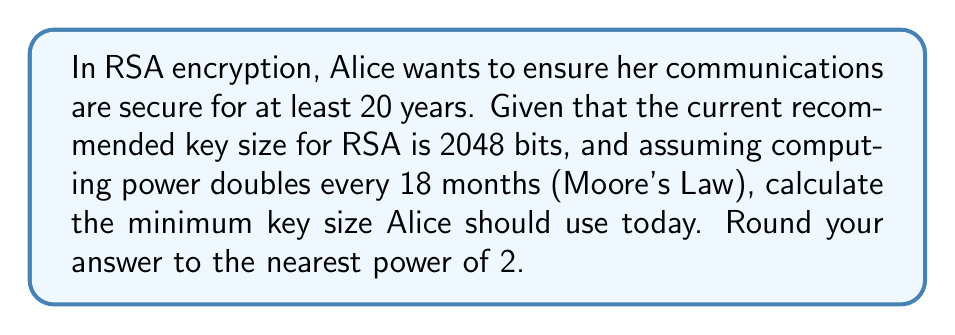Teach me how to tackle this problem. Let's approach this step-by-step:

1) First, we need to calculate how many times computing power will double in 20 years:
   - 20 years = 240 months
   - Number of doublings = 240 / 18 = 13.33

2) Now, we can calculate the factor by which computing power will increase:
   $2^{13.33} \approx 10,321$

3) This means that a 2048-bit key in 20 years will be as secure as a 2048/10,321 ≈ 198-bit key today.

4) To maintain the same level of security, Alice needs to use a key that is 10,321 times larger than 2048 bits:
   $2048 * 10,321 = 21,137,408$ bits

5) Rounding to the nearest power of 2:
   $2^{24} = 16,777,216$ (too small)
   $2^{25} = 33,554,432$ (closest)

Therefore, Alice should use a 33,554,432-bit (2^25) key to ensure her communications remain secure for at least 20 years.
Answer: $2^{25}$ bits 